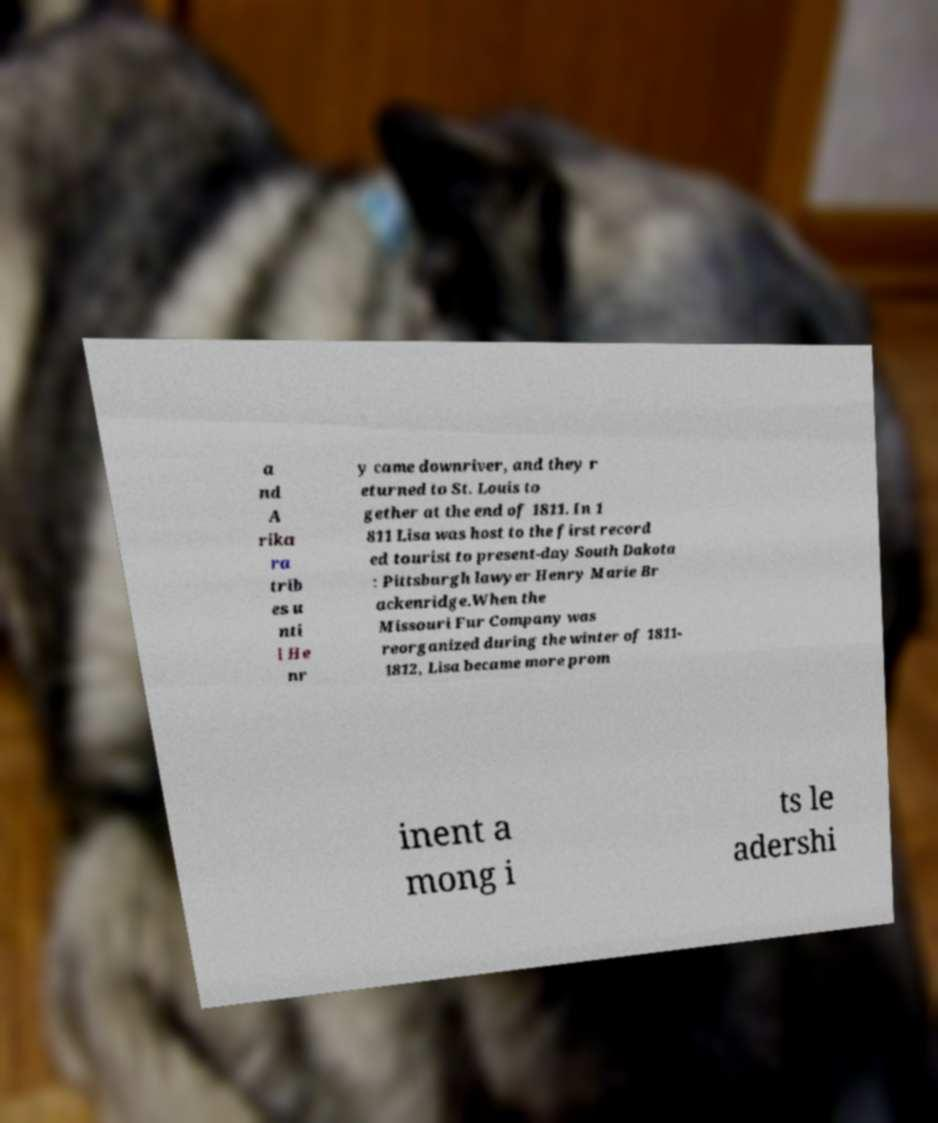I need the written content from this picture converted into text. Can you do that? a nd A rika ra trib es u nti l He nr y came downriver, and they r eturned to St. Louis to gether at the end of 1811. In 1 811 Lisa was host to the first record ed tourist to present-day South Dakota : Pittsburgh lawyer Henry Marie Br ackenridge.When the Missouri Fur Company was reorganized during the winter of 1811- 1812, Lisa became more prom inent a mong i ts le adershi 